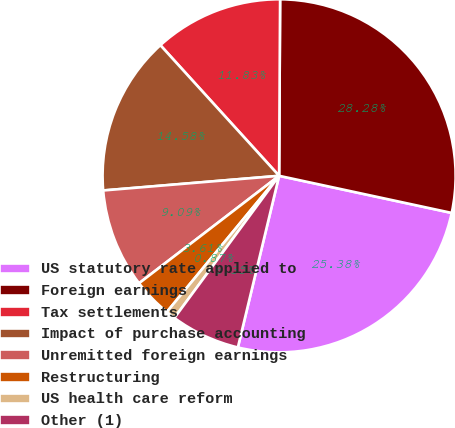<chart> <loc_0><loc_0><loc_500><loc_500><pie_chart><fcel>US statutory rate applied to<fcel>Foreign earnings<fcel>Tax settlements<fcel>Impact of purchase accounting<fcel>Unremitted foreign earnings<fcel>Restructuring<fcel>US health care reform<fcel>Other (1)<nl><fcel>25.38%<fcel>28.28%<fcel>11.83%<fcel>14.58%<fcel>9.09%<fcel>3.61%<fcel>0.87%<fcel>6.35%<nl></chart> 